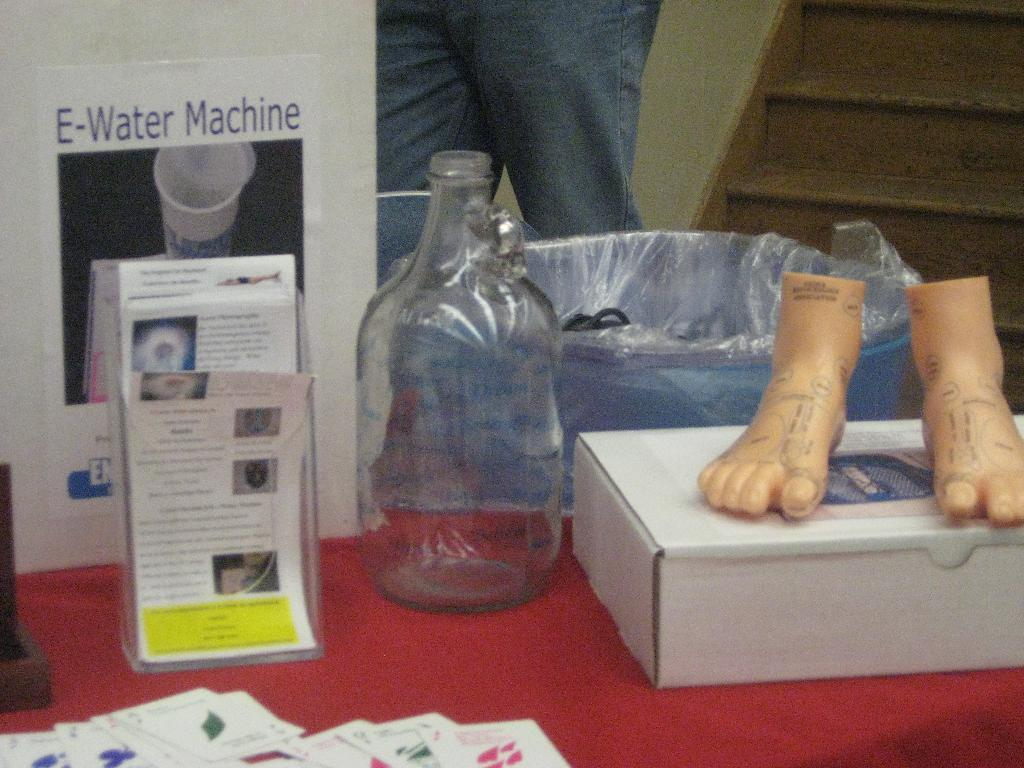What type of object can be seen in the image? There is a bottle in the image. What other objects are present in the image? There is a container, a box, and a paper in the image. Is there a person in the image? Yes, there is a person in the image. What is the person in the image thinking about? There is no information about the person's thoughts in the image, so it cannot be determined. 